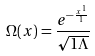<formula> <loc_0><loc_0><loc_500><loc_500>\Omega ( x ) = \frac { e ^ { - \frac { x ^ { 1 } } { 1 } } } { \sqrt { 1 \Lambda } }</formula> 